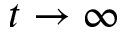<formula> <loc_0><loc_0><loc_500><loc_500>t \rightarrow \infty</formula> 